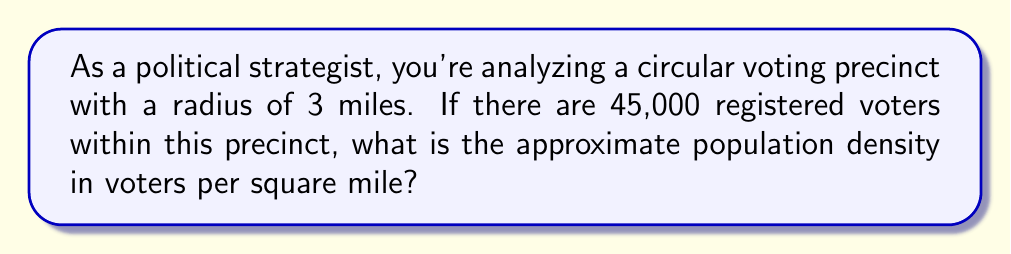Teach me how to tackle this problem. To solve this problem, we need to follow these steps:

1. Calculate the area of the circular precinct:
   The area of a circle is given by the formula $A = \pi r^2$
   where $r$ is the radius.
   
   $A = \pi (3 \text{ miles})^2 = 9\pi \text{ square miles}$

2. Calculate the population density:
   Population density is defined as the number of people (in this case, voters) per unit area.
   
   Density = $\frac{\text{Number of voters}}{\text{Area}}$

   $\text{Density} = \frac{45,000 \text{ voters}}{9\pi \text{ square miles}}$

3. Simplify the expression:
   $\text{Density} = \frac{5,000}{\pi} \text{ voters per square mile}$

4. Calculate the approximate value:
   $\frac{5,000}{\pi} \approx 1,591.55 \text{ voters per square mile}$

Therefore, the approximate population density is 1,592 voters per square mile (rounded to the nearest whole number).
Answer: 1,592 voters/sq mi 